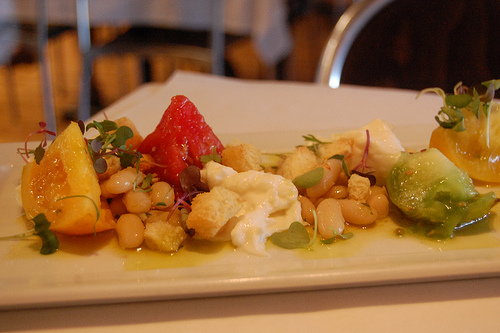<image>
Is there a tomato on the plate? Yes. Looking at the image, I can see the tomato is positioned on top of the plate, with the plate providing support. 